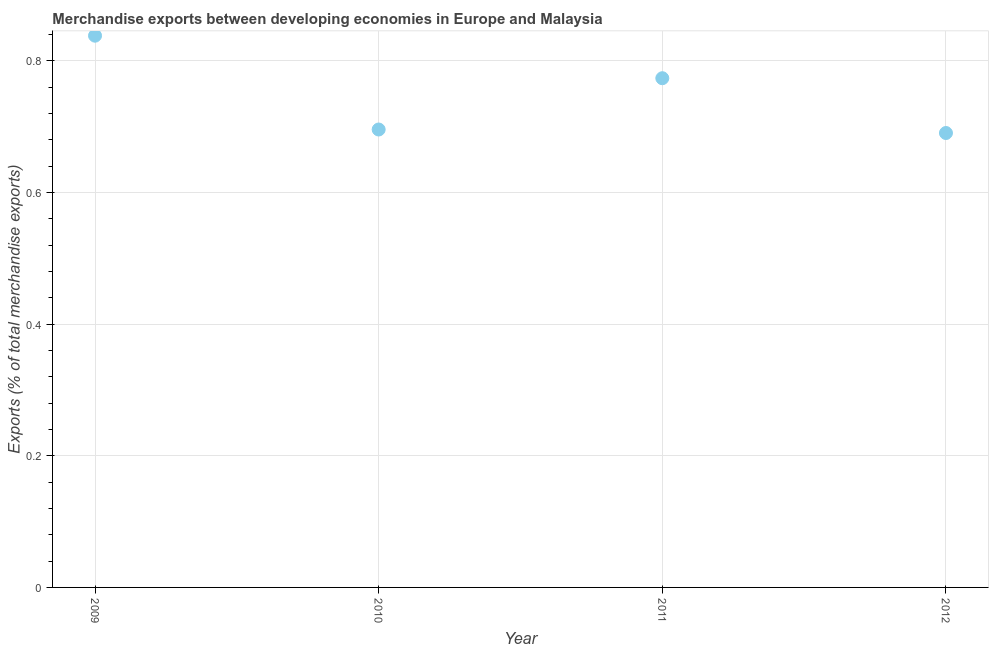What is the merchandise exports in 2011?
Offer a terse response. 0.77. Across all years, what is the maximum merchandise exports?
Provide a succinct answer. 0.84. Across all years, what is the minimum merchandise exports?
Your answer should be compact. 0.69. In which year was the merchandise exports minimum?
Offer a very short reply. 2012. What is the sum of the merchandise exports?
Give a very brief answer. 3. What is the difference between the merchandise exports in 2011 and 2012?
Your answer should be very brief. 0.08. What is the average merchandise exports per year?
Offer a very short reply. 0.75. What is the median merchandise exports?
Offer a very short reply. 0.73. In how many years, is the merchandise exports greater than 0.52 %?
Provide a short and direct response. 4. What is the ratio of the merchandise exports in 2011 to that in 2012?
Provide a succinct answer. 1.12. Is the difference between the merchandise exports in 2009 and 2012 greater than the difference between any two years?
Your answer should be compact. Yes. What is the difference between the highest and the second highest merchandise exports?
Your response must be concise. 0.06. What is the difference between the highest and the lowest merchandise exports?
Your answer should be very brief. 0.15. Does the merchandise exports monotonically increase over the years?
Provide a succinct answer. No. How many years are there in the graph?
Your answer should be very brief. 4. What is the title of the graph?
Give a very brief answer. Merchandise exports between developing economies in Europe and Malaysia. What is the label or title of the X-axis?
Your answer should be compact. Year. What is the label or title of the Y-axis?
Your answer should be very brief. Exports (% of total merchandise exports). What is the Exports (% of total merchandise exports) in 2009?
Provide a short and direct response. 0.84. What is the Exports (% of total merchandise exports) in 2010?
Make the answer very short. 0.7. What is the Exports (% of total merchandise exports) in 2011?
Your answer should be very brief. 0.77. What is the Exports (% of total merchandise exports) in 2012?
Your response must be concise. 0.69. What is the difference between the Exports (% of total merchandise exports) in 2009 and 2010?
Make the answer very short. 0.14. What is the difference between the Exports (% of total merchandise exports) in 2009 and 2011?
Keep it short and to the point. 0.06. What is the difference between the Exports (% of total merchandise exports) in 2009 and 2012?
Make the answer very short. 0.15. What is the difference between the Exports (% of total merchandise exports) in 2010 and 2011?
Your answer should be compact. -0.08. What is the difference between the Exports (% of total merchandise exports) in 2010 and 2012?
Offer a very short reply. 0.01. What is the difference between the Exports (% of total merchandise exports) in 2011 and 2012?
Your answer should be compact. 0.08. What is the ratio of the Exports (% of total merchandise exports) in 2009 to that in 2010?
Provide a succinct answer. 1.21. What is the ratio of the Exports (% of total merchandise exports) in 2009 to that in 2011?
Your answer should be very brief. 1.08. What is the ratio of the Exports (% of total merchandise exports) in 2009 to that in 2012?
Your answer should be very brief. 1.21. What is the ratio of the Exports (% of total merchandise exports) in 2010 to that in 2011?
Your answer should be compact. 0.9. What is the ratio of the Exports (% of total merchandise exports) in 2010 to that in 2012?
Provide a succinct answer. 1.01. What is the ratio of the Exports (% of total merchandise exports) in 2011 to that in 2012?
Your answer should be very brief. 1.12. 